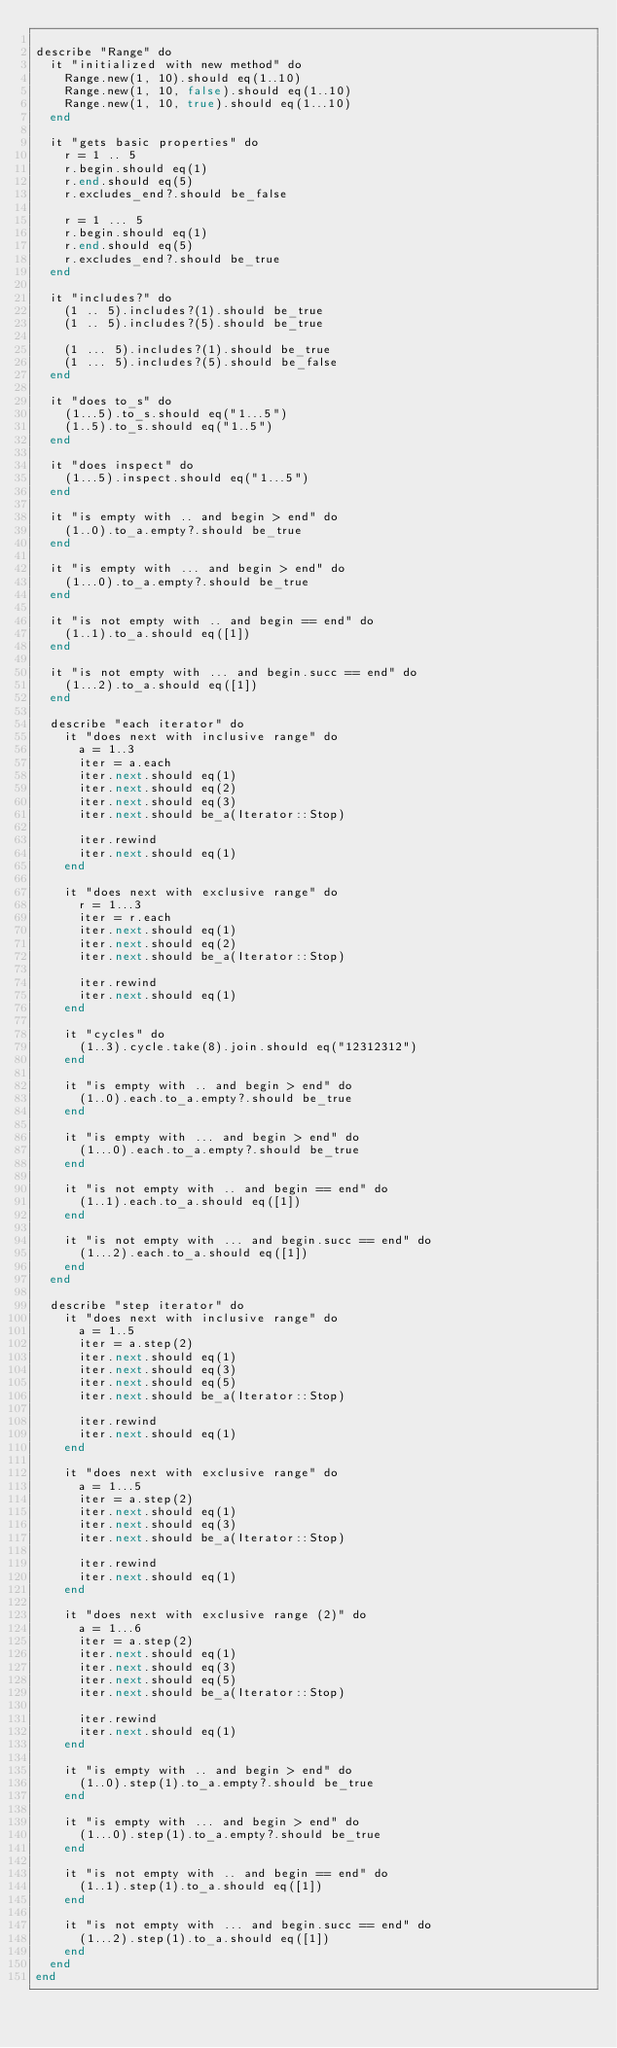Convert code to text. <code><loc_0><loc_0><loc_500><loc_500><_Crystal_>
describe "Range" do
  it "initialized with new method" do
    Range.new(1, 10).should eq(1..10)
    Range.new(1, 10, false).should eq(1..10)
    Range.new(1, 10, true).should eq(1...10)
  end

  it "gets basic properties" do
    r = 1 .. 5
    r.begin.should eq(1)
    r.end.should eq(5)
    r.excludes_end?.should be_false

    r = 1 ... 5
    r.begin.should eq(1)
    r.end.should eq(5)
    r.excludes_end?.should be_true
  end

  it "includes?" do
    (1 .. 5).includes?(1).should be_true
    (1 .. 5).includes?(5).should be_true

    (1 ... 5).includes?(1).should be_true
    (1 ... 5).includes?(5).should be_false
  end

  it "does to_s" do
    (1...5).to_s.should eq("1...5")
    (1..5).to_s.should eq("1..5")
  end

  it "does inspect" do
    (1...5).inspect.should eq("1...5")
  end

  it "is empty with .. and begin > end" do
    (1..0).to_a.empty?.should be_true
  end

  it "is empty with ... and begin > end" do
    (1...0).to_a.empty?.should be_true
  end

  it "is not empty with .. and begin == end" do
    (1..1).to_a.should eq([1])
  end

  it "is not empty with ... and begin.succ == end" do
    (1...2).to_a.should eq([1])
  end

  describe "each iterator" do
    it "does next with inclusive range" do
      a = 1..3
      iter = a.each
      iter.next.should eq(1)
      iter.next.should eq(2)
      iter.next.should eq(3)
      iter.next.should be_a(Iterator::Stop)

      iter.rewind
      iter.next.should eq(1)
    end

    it "does next with exclusive range" do
      r = 1...3
      iter = r.each
      iter.next.should eq(1)
      iter.next.should eq(2)
      iter.next.should be_a(Iterator::Stop)

      iter.rewind
      iter.next.should eq(1)
    end

    it "cycles" do
      (1..3).cycle.take(8).join.should eq("12312312")
    end

    it "is empty with .. and begin > end" do
      (1..0).each.to_a.empty?.should be_true
    end

    it "is empty with ... and begin > end" do
      (1...0).each.to_a.empty?.should be_true
    end

    it "is not empty with .. and begin == end" do
      (1..1).each.to_a.should eq([1])
    end

    it "is not empty with ... and begin.succ == end" do
      (1...2).each.to_a.should eq([1])
    end
  end

  describe "step iterator" do
    it "does next with inclusive range" do
      a = 1..5
      iter = a.step(2)
      iter.next.should eq(1)
      iter.next.should eq(3)
      iter.next.should eq(5)
      iter.next.should be_a(Iterator::Stop)

      iter.rewind
      iter.next.should eq(1)
    end

    it "does next with exclusive range" do
      a = 1...5
      iter = a.step(2)
      iter.next.should eq(1)
      iter.next.should eq(3)
      iter.next.should be_a(Iterator::Stop)

      iter.rewind
      iter.next.should eq(1)
    end

    it "does next with exclusive range (2)" do
      a = 1...6
      iter = a.step(2)
      iter.next.should eq(1)
      iter.next.should eq(3)
      iter.next.should eq(5)
      iter.next.should be_a(Iterator::Stop)

      iter.rewind
      iter.next.should eq(1)
    end

    it "is empty with .. and begin > end" do
      (1..0).step(1).to_a.empty?.should be_true
    end

    it "is empty with ... and begin > end" do
      (1...0).step(1).to_a.empty?.should be_true
    end

    it "is not empty with .. and begin == end" do
      (1..1).step(1).to_a.should eq([1])
    end

    it "is not empty with ... and begin.succ == end" do
      (1...2).step(1).to_a.should eq([1])
    end
  end
end
</code> 